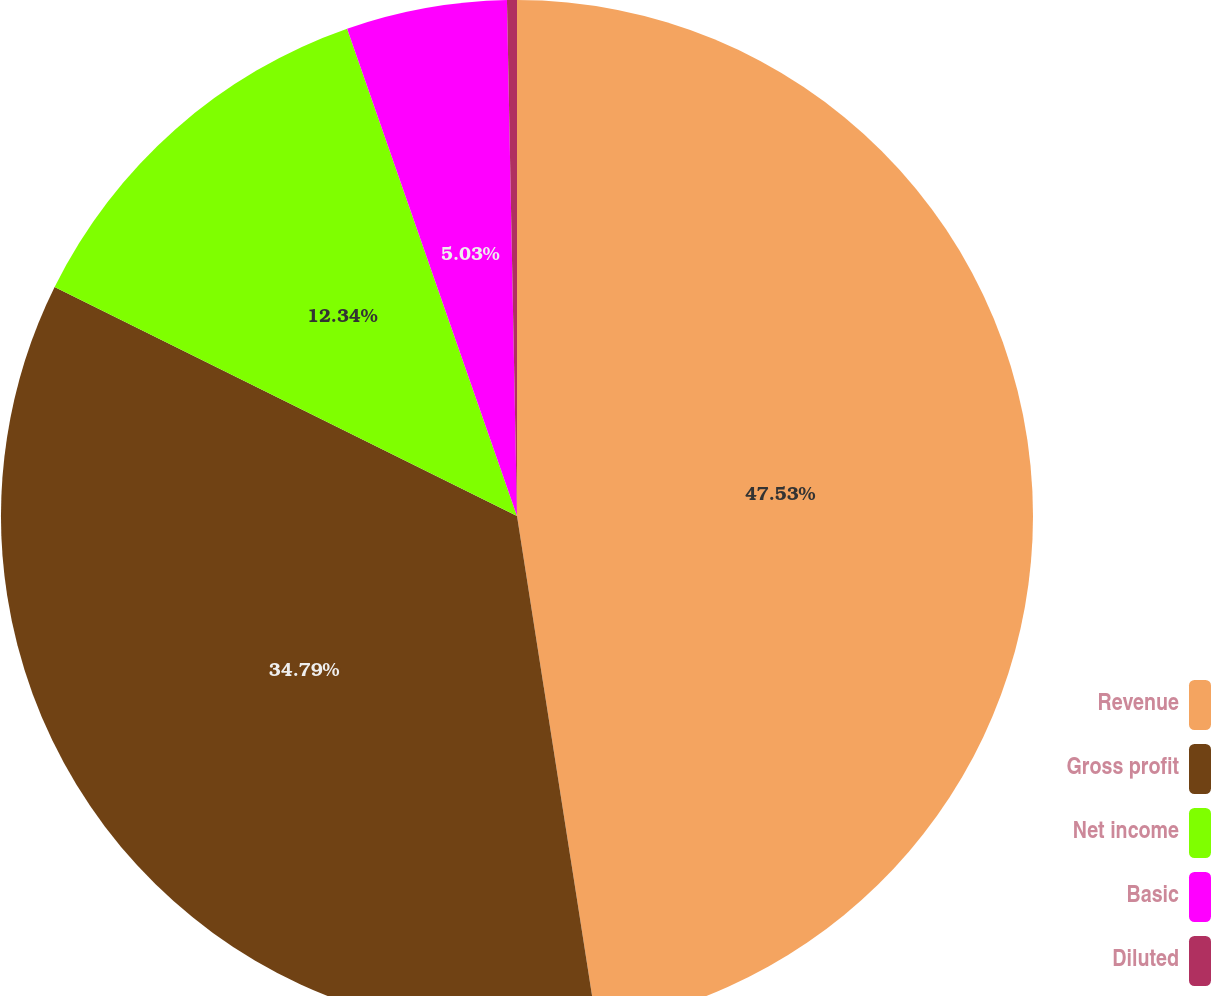Convert chart. <chart><loc_0><loc_0><loc_500><loc_500><pie_chart><fcel>Revenue<fcel>Gross profit<fcel>Net income<fcel>Basic<fcel>Diluted<nl><fcel>47.53%<fcel>34.79%<fcel>12.34%<fcel>5.03%<fcel>0.31%<nl></chart> 